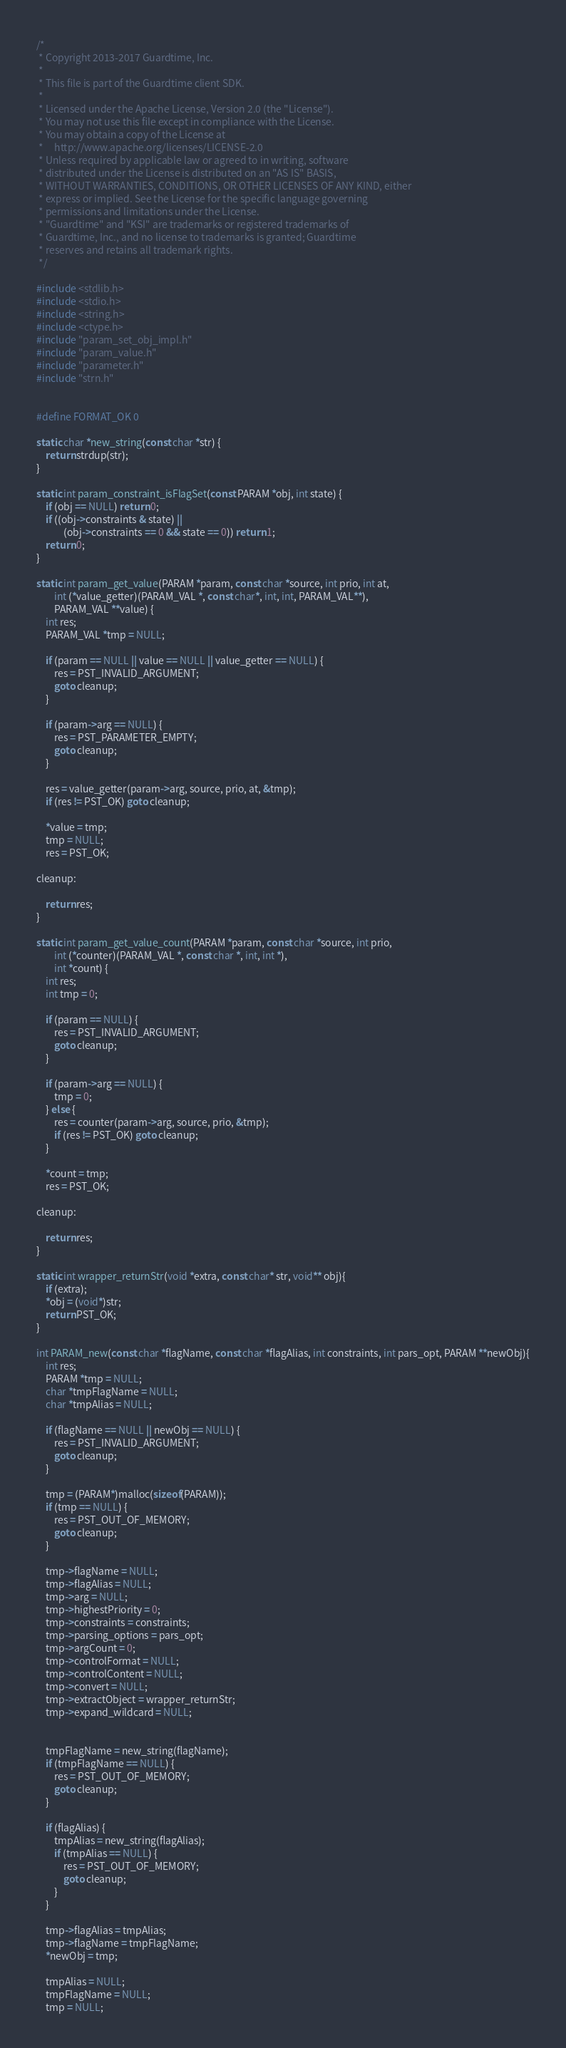<code> <loc_0><loc_0><loc_500><loc_500><_C_>/*
 * Copyright 2013-2017 Guardtime, Inc.
 *
 * This file is part of the Guardtime client SDK.
 *
 * Licensed under the Apache License, Version 2.0 (the "License").
 * You may not use this file except in compliance with the License.
 * You may obtain a copy of the License at
 *     http://www.apache.org/licenses/LICENSE-2.0
 * Unless required by applicable law or agreed to in writing, software
 * distributed under the License is distributed on an "AS IS" BASIS,
 * WITHOUT WARRANTIES, CONDITIONS, OR OTHER LICENSES OF ANY KIND, either
 * express or implied. See the License for the specific language governing
 * permissions and limitations under the License.
 * "Guardtime" and "KSI" are trademarks or registered trademarks of
 * Guardtime, Inc., and no license to trademarks is granted; Guardtime
 * reserves and retains all trademark rights.
 */

#include <stdlib.h>
#include <stdio.h>
#include <string.h>
#include <ctype.h>
#include "param_set_obj_impl.h"
#include "param_value.h"
#include "parameter.h"
#include "strn.h"


#define FORMAT_OK 0

static char *new_string(const char *str) {
	return strdup(str);
}

static int param_constraint_isFlagSet(const PARAM *obj, int state) {
	if (obj == NULL) return 0;
	if ((obj->constraints & state) ||
			(obj->constraints == 0 && state == 0)) return 1;
	return 0;
}

static int param_get_value(PARAM *param, const char *source, int prio, int at,
		int (*value_getter)(PARAM_VAL *, const char*, int, int, PARAM_VAL**),
		PARAM_VAL **value) {
	int res;
	PARAM_VAL *tmp = NULL;

	if (param == NULL || value == NULL || value_getter == NULL) {
		res = PST_INVALID_ARGUMENT;
		goto cleanup;
	}

	if (param->arg == NULL) {
		res = PST_PARAMETER_EMPTY;
		goto cleanup;
	}

	res = value_getter(param->arg, source, prio, at, &tmp);
	if (res != PST_OK) goto cleanup;

	*value = tmp;
	tmp = NULL;
	res = PST_OK;

cleanup:

	return res;
}

static int param_get_value_count(PARAM *param, const char *source, int prio,
		int (*counter)(PARAM_VAL *, const char *, int, int *),
		int *count) {
	int res;
	int tmp = 0;

	if (param == NULL) {
		res = PST_INVALID_ARGUMENT;
		goto cleanup;
	}

	if (param->arg == NULL) {
		tmp = 0;
	} else {
		res = counter(param->arg, source, prio, &tmp);
		if (res != PST_OK) goto cleanup;
	}

	*count = tmp;
	res = PST_OK;

cleanup:

	return res;
}

static int wrapper_returnStr(void *extra, const char* str, void** obj){
	if (extra);
	*obj = (void*)str;
	return PST_OK;
}

int PARAM_new(const char *flagName, const char *flagAlias, int constraints, int pars_opt, PARAM **newObj){
	int res;
	PARAM *tmp = NULL;
	char *tmpFlagName = NULL;
	char *tmpAlias = NULL;

	if (flagName == NULL || newObj == NULL) {
		res = PST_INVALID_ARGUMENT;
		goto cleanup;
	}

	tmp = (PARAM*)malloc(sizeof(PARAM));
	if (tmp == NULL) {
		res = PST_OUT_OF_MEMORY;
		goto cleanup;
	}

	tmp->flagName = NULL;
	tmp->flagAlias = NULL;
	tmp->arg = NULL;
	tmp->highestPriority = 0;
	tmp->constraints = constraints;
	tmp->parsing_options = pars_opt;
	tmp->argCount = 0;
	tmp->controlFormat = NULL;
	tmp->controlContent = NULL;
	tmp->convert = NULL;
	tmp->extractObject = wrapper_returnStr;
	tmp->expand_wildcard = NULL;


	tmpFlagName = new_string(flagName);
	if (tmpFlagName == NULL) {
		res = PST_OUT_OF_MEMORY;
		goto cleanup;
	}

	if (flagAlias) {
		tmpAlias = new_string(flagAlias);
		if (tmpAlias == NULL) {
			res = PST_OUT_OF_MEMORY;
			goto cleanup;
		}
	}

	tmp->flagAlias = tmpAlias;
	tmp->flagName = tmpFlagName;
	*newObj = tmp;

	tmpAlias = NULL;
	tmpFlagName = NULL;
	tmp = NULL;
</code> 